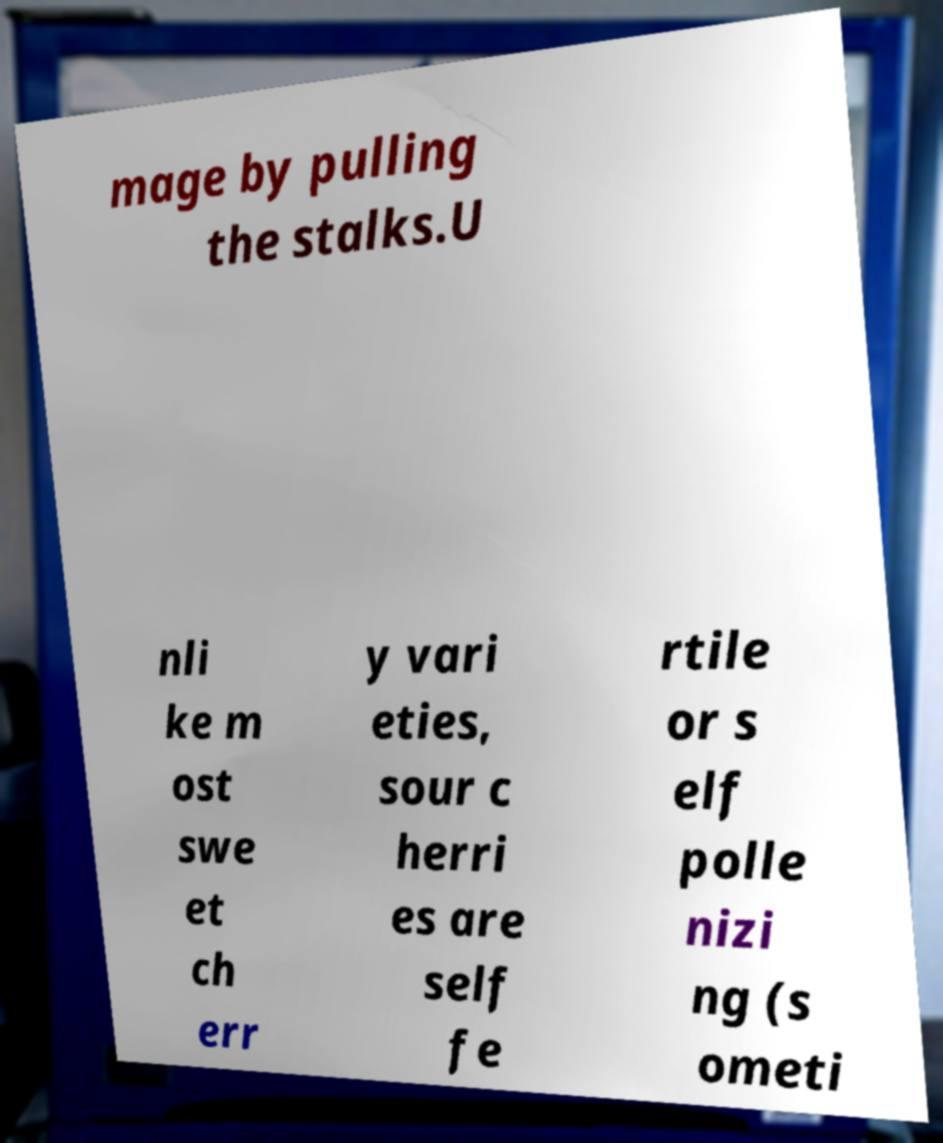For documentation purposes, I need the text within this image transcribed. Could you provide that? mage by pulling the stalks.U nli ke m ost swe et ch err y vari eties, sour c herri es are self fe rtile or s elf polle nizi ng (s ometi 